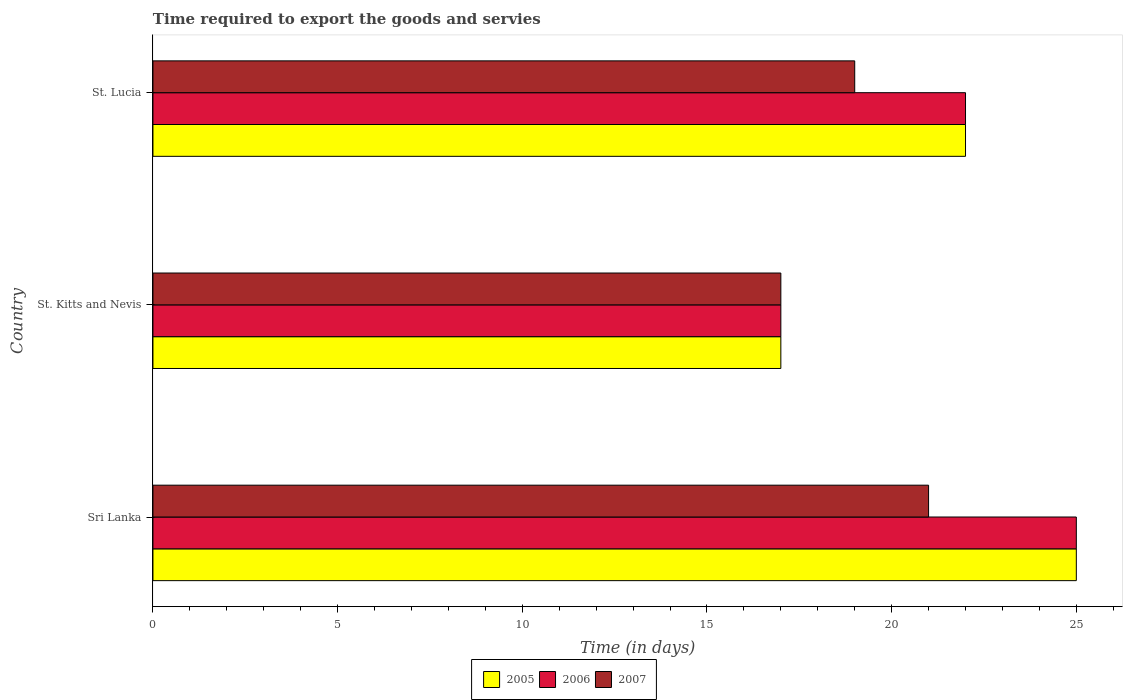How many different coloured bars are there?
Ensure brevity in your answer.  3. Are the number of bars on each tick of the Y-axis equal?
Your answer should be very brief. Yes. How many bars are there on the 2nd tick from the bottom?
Offer a very short reply. 3. What is the label of the 2nd group of bars from the top?
Ensure brevity in your answer.  St. Kitts and Nevis. In which country was the number of days required to export the goods and services in 2007 maximum?
Your answer should be very brief. Sri Lanka. In which country was the number of days required to export the goods and services in 2007 minimum?
Ensure brevity in your answer.  St. Kitts and Nevis. What is the difference between the number of days required to export the goods and services in 2005 in Sri Lanka and that in St. Kitts and Nevis?
Offer a very short reply. 8. What is the average number of days required to export the goods and services in 2006 per country?
Provide a succinct answer. 21.33. What is the difference between the number of days required to export the goods and services in 2007 and number of days required to export the goods and services in 2006 in Sri Lanka?
Keep it short and to the point. -4. In how many countries, is the number of days required to export the goods and services in 2005 greater than 8 days?
Offer a terse response. 3. What is the ratio of the number of days required to export the goods and services in 2006 in St. Kitts and Nevis to that in St. Lucia?
Give a very brief answer. 0.77. Is the number of days required to export the goods and services in 2006 in Sri Lanka less than that in St. Kitts and Nevis?
Offer a terse response. No. What is the difference between the highest and the lowest number of days required to export the goods and services in 2007?
Provide a short and direct response. 4. What does the 3rd bar from the top in Sri Lanka represents?
Your answer should be compact. 2005. How many bars are there?
Your answer should be very brief. 9. What is the title of the graph?
Offer a terse response. Time required to export the goods and servies. Does "1999" appear as one of the legend labels in the graph?
Offer a very short reply. No. What is the label or title of the X-axis?
Ensure brevity in your answer.  Time (in days). What is the Time (in days) in 2006 in Sri Lanka?
Your answer should be very brief. 25. What is the Time (in days) of 2005 in St. Kitts and Nevis?
Your answer should be compact. 17. What is the Time (in days) of 2006 in St. Kitts and Nevis?
Your answer should be compact. 17. What is the Time (in days) in 2005 in St. Lucia?
Your answer should be compact. 22. What is the Time (in days) in 2006 in St. Lucia?
Ensure brevity in your answer.  22. What is the Time (in days) in 2007 in St. Lucia?
Make the answer very short. 19. Across all countries, what is the maximum Time (in days) in 2007?
Provide a succinct answer. 21. What is the total Time (in days) of 2005 in the graph?
Offer a very short reply. 64. What is the difference between the Time (in days) of 2006 in Sri Lanka and that in St. Kitts and Nevis?
Keep it short and to the point. 8. What is the difference between the Time (in days) of 2005 in Sri Lanka and that in St. Lucia?
Provide a short and direct response. 3. What is the difference between the Time (in days) in 2005 in St. Kitts and Nevis and that in St. Lucia?
Make the answer very short. -5. What is the difference between the Time (in days) in 2006 in St. Kitts and Nevis and that in St. Lucia?
Provide a short and direct response. -5. What is the difference between the Time (in days) in 2005 in Sri Lanka and the Time (in days) in 2006 in St. Kitts and Nevis?
Your answer should be very brief. 8. What is the difference between the Time (in days) of 2005 in Sri Lanka and the Time (in days) of 2007 in St. Kitts and Nevis?
Your answer should be very brief. 8. What is the difference between the Time (in days) in 2006 in Sri Lanka and the Time (in days) in 2007 in St. Kitts and Nevis?
Your answer should be very brief. 8. What is the difference between the Time (in days) of 2006 in Sri Lanka and the Time (in days) of 2007 in St. Lucia?
Your answer should be very brief. 6. What is the difference between the Time (in days) in 2005 in St. Kitts and Nevis and the Time (in days) in 2006 in St. Lucia?
Offer a very short reply. -5. What is the average Time (in days) of 2005 per country?
Offer a terse response. 21.33. What is the average Time (in days) of 2006 per country?
Keep it short and to the point. 21.33. What is the average Time (in days) of 2007 per country?
Ensure brevity in your answer.  19. What is the difference between the Time (in days) of 2005 and Time (in days) of 2007 in Sri Lanka?
Your answer should be compact. 4. What is the difference between the Time (in days) of 2005 and Time (in days) of 2007 in St. Lucia?
Ensure brevity in your answer.  3. What is the ratio of the Time (in days) in 2005 in Sri Lanka to that in St. Kitts and Nevis?
Offer a very short reply. 1.47. What is the ratio of the Time (in days) of 2006 in Sri Lanka to that in St. Kitts and Nevis?
Keep it short and to the point. 1.47. What is the ratio of the Time (in days) in 2007 in Sri Lanka to that in St. Kitts and Nevis?
Your answer should be compact. 1.24. What is the ratio of the Time (in days) in 2005 in Sri Lanka to that in St. Lucia?
Your answer should be very brief. 1.14. What is the ratio of the Time (in days) in 2006 in Sri Lanka to that in St. Lucia?
Offer a very short reply. 1.14. What is the ratio of the Time (in days) of 2007 in Sri Lanka to that in St. Lucia?
Ensure brevity in your answer.  1.11. What is the ratio of the Time (in days) in 2005 in St. Kitts and Nevis to that in St. Lucia?
Make the answer very short. 0.77. What is the ratio of the Time (in days) in 2006 in St. Kitts and Nevis to that in St. Lucia?
Offer a very short reply. 0.77. What is the ratio of the Time (in days) of 2007 in St. Kitts and Nevis to that in St. Lucia?
Offer a very short reply. 0.89. What is the difference between the highest and the second highest Time (in days) of 2005?
Your answer should be compact. 3. What is the difference between the highest and the second highest Time (in days) in 2006?
Provide a succinct answer. 3. What is the difference between the highest and the second highest Time (in days) of 2007?
Offer a terse response. 2. What is the difference between the highest and the lowest Time (in days) of 2005?
Give a very brief answer. 8. What is the difference between the highest and the lowest Time (in days) in 2007?
Give a very brief answer. 4. 